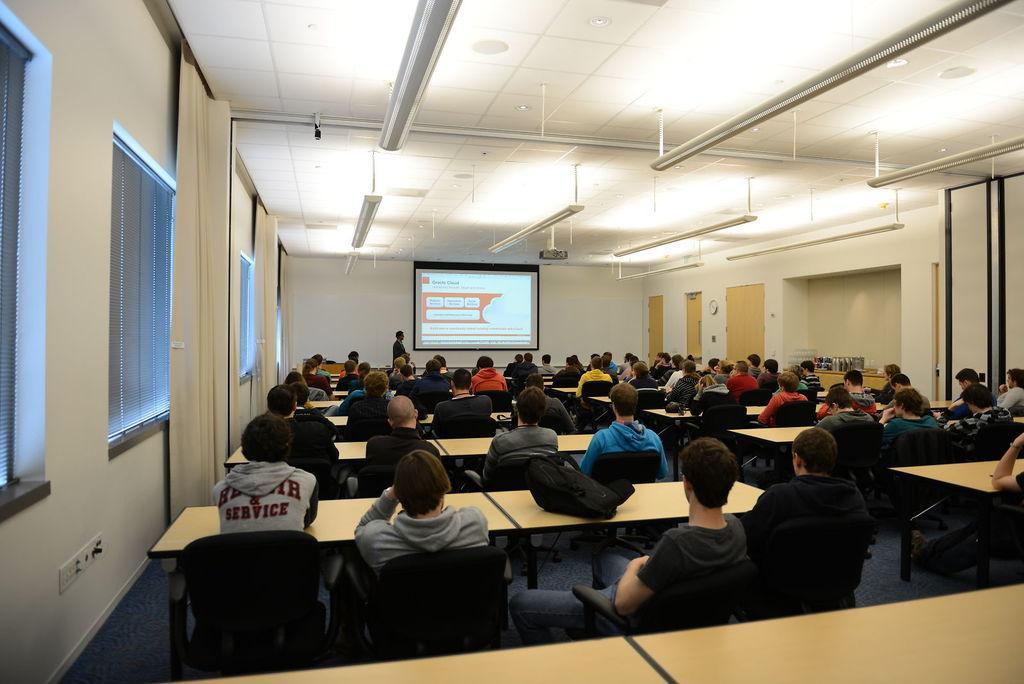Could you give a brief overview of what you see in this image? In this picture there are many people sitting in the chairs, in front of a tables in a room. In the background, there is a projector display screen here to the wall and one guy standing near the screen. We can observe some curtains and windows here. 